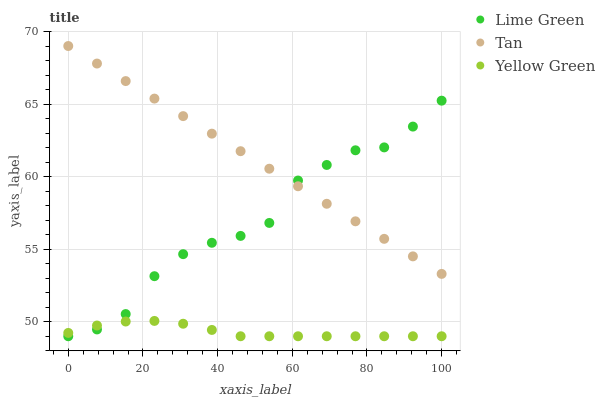Does Yellow Green have the minimum area under the curve?
Answer yes or no. Yes. Does Tan have the maximum area under the curve?
Answer yes or no. Yes. Does Lime Green have the minimum area under the curve?
Answer yes or no. No. Does Lime Green have the maximum area under the curve?
Answer yes or no. No. Is Tan the smoothest?
Answer yes or no. Yes. Is Lime Green the roughest?
Answer yes or no. Yes. Is Yellow Green the smoothest?
Answer yes or no. No. Is Yellow Green the roughest?
Answer yes or no. No. Does Lime Green have the lowest value?
Answer yes or no. Yes. Does Tan have the highest value?
Answer yes or no. Yes. Does Lime Green have the highest value?
Answer yes or no. No. Is Yellow Green less than Tan?
Answer yes or no. Yes. Is Tan greater than Yellow Green?
Answer yes or no. Yes. Does Yellow Green intersect Lime Green?
Answer yes or no. Yes. Is Yellow Green less than Lime Green?
Answer yes or no. No. Is Yellow Green greater than Lime Green?
Answer yes or no. No. Does Yellow Green intersect Tan?
Answer yes or no. No. 